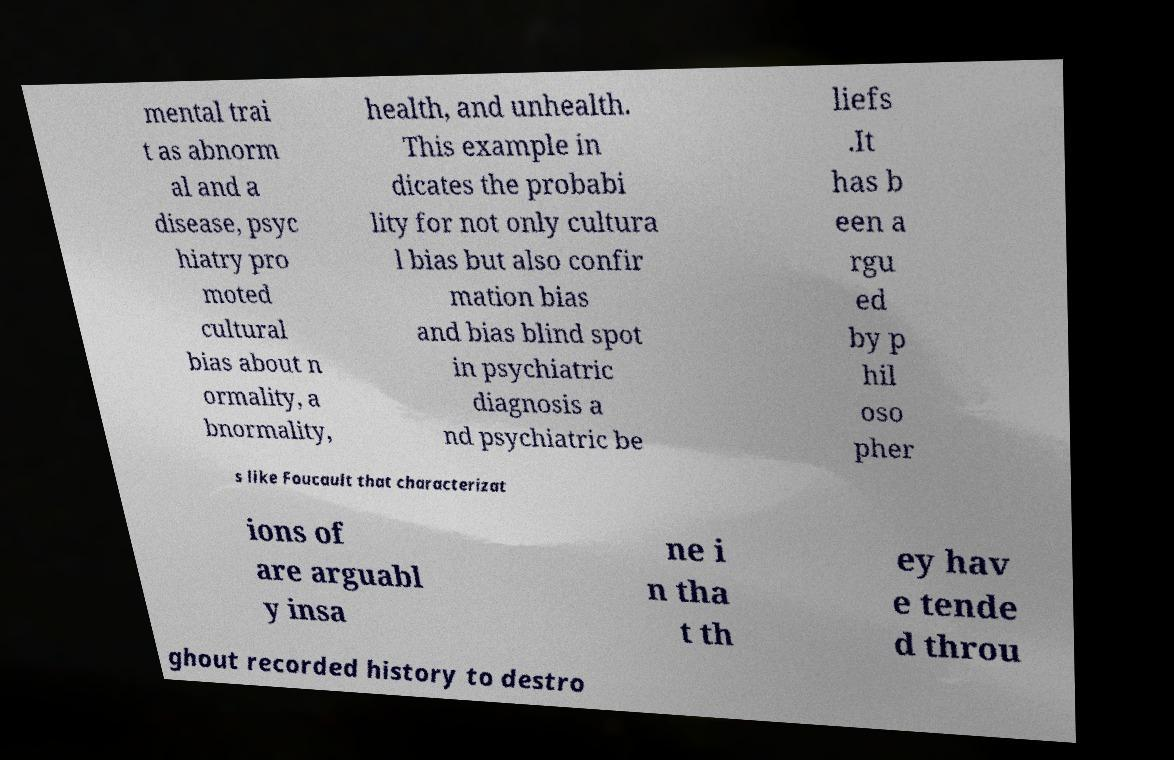What messages or text are displayed in this image? I need them in a readable, typed format. mental trai t as abnorm al and a disease, psyc hiatry pro moted cultural bias about n ormality, a bnormality, health, and unhealth. This example in dicates the probabi lity for not only cultura l bias but also confir mation bias and bias blind spot in psychiatric diagnosis a nd psychiatric be liefs .It has b een a rgu ed by p hil oso pher s like Foucault that characterizat ions of are arguabl y insa ne i n tha t th ey hav e tende d throu ghout recorded history to destro 